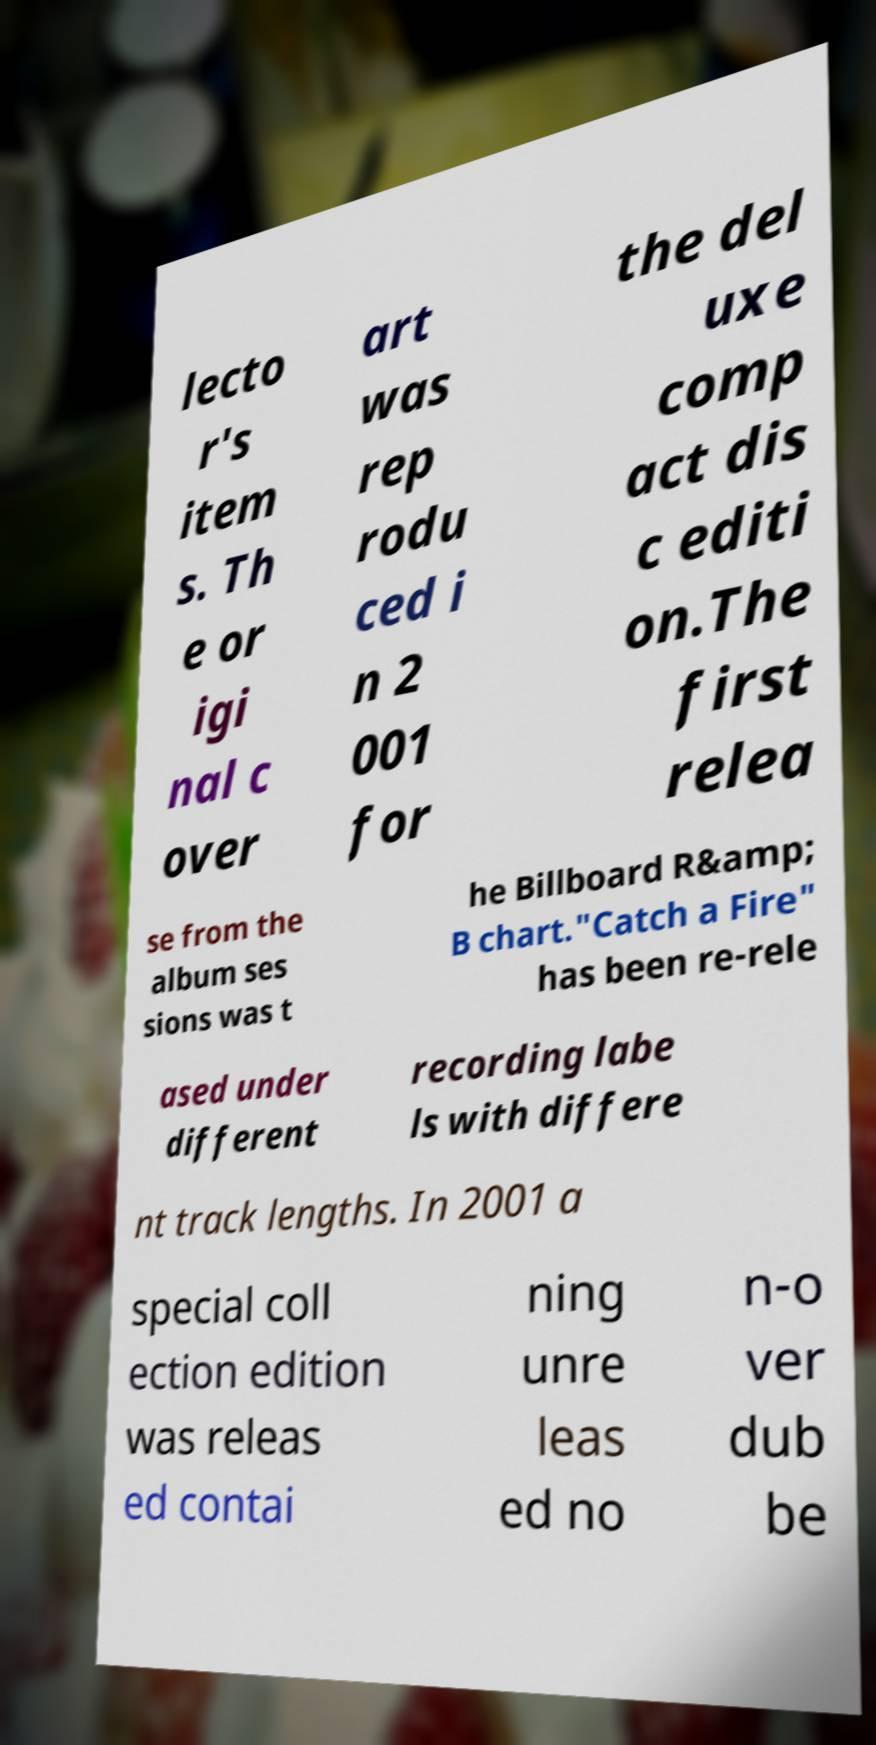Could you assist in decoding the text presented in this image and type it out clearly? lecto r's item s. Th e or igi nal c over art was rep rodu ced i n 2 001 for the del uxe comp act dis c editi on.The first relea se from the album ses sions was t he Billboard R&amp; B chart."Catch a Fire" has been re-rele ased under different recording labe ls with differe nt track lengths. In 2001 a special coll ection edition was releas ed contai ning unre leas ed no n-o ver dub be 